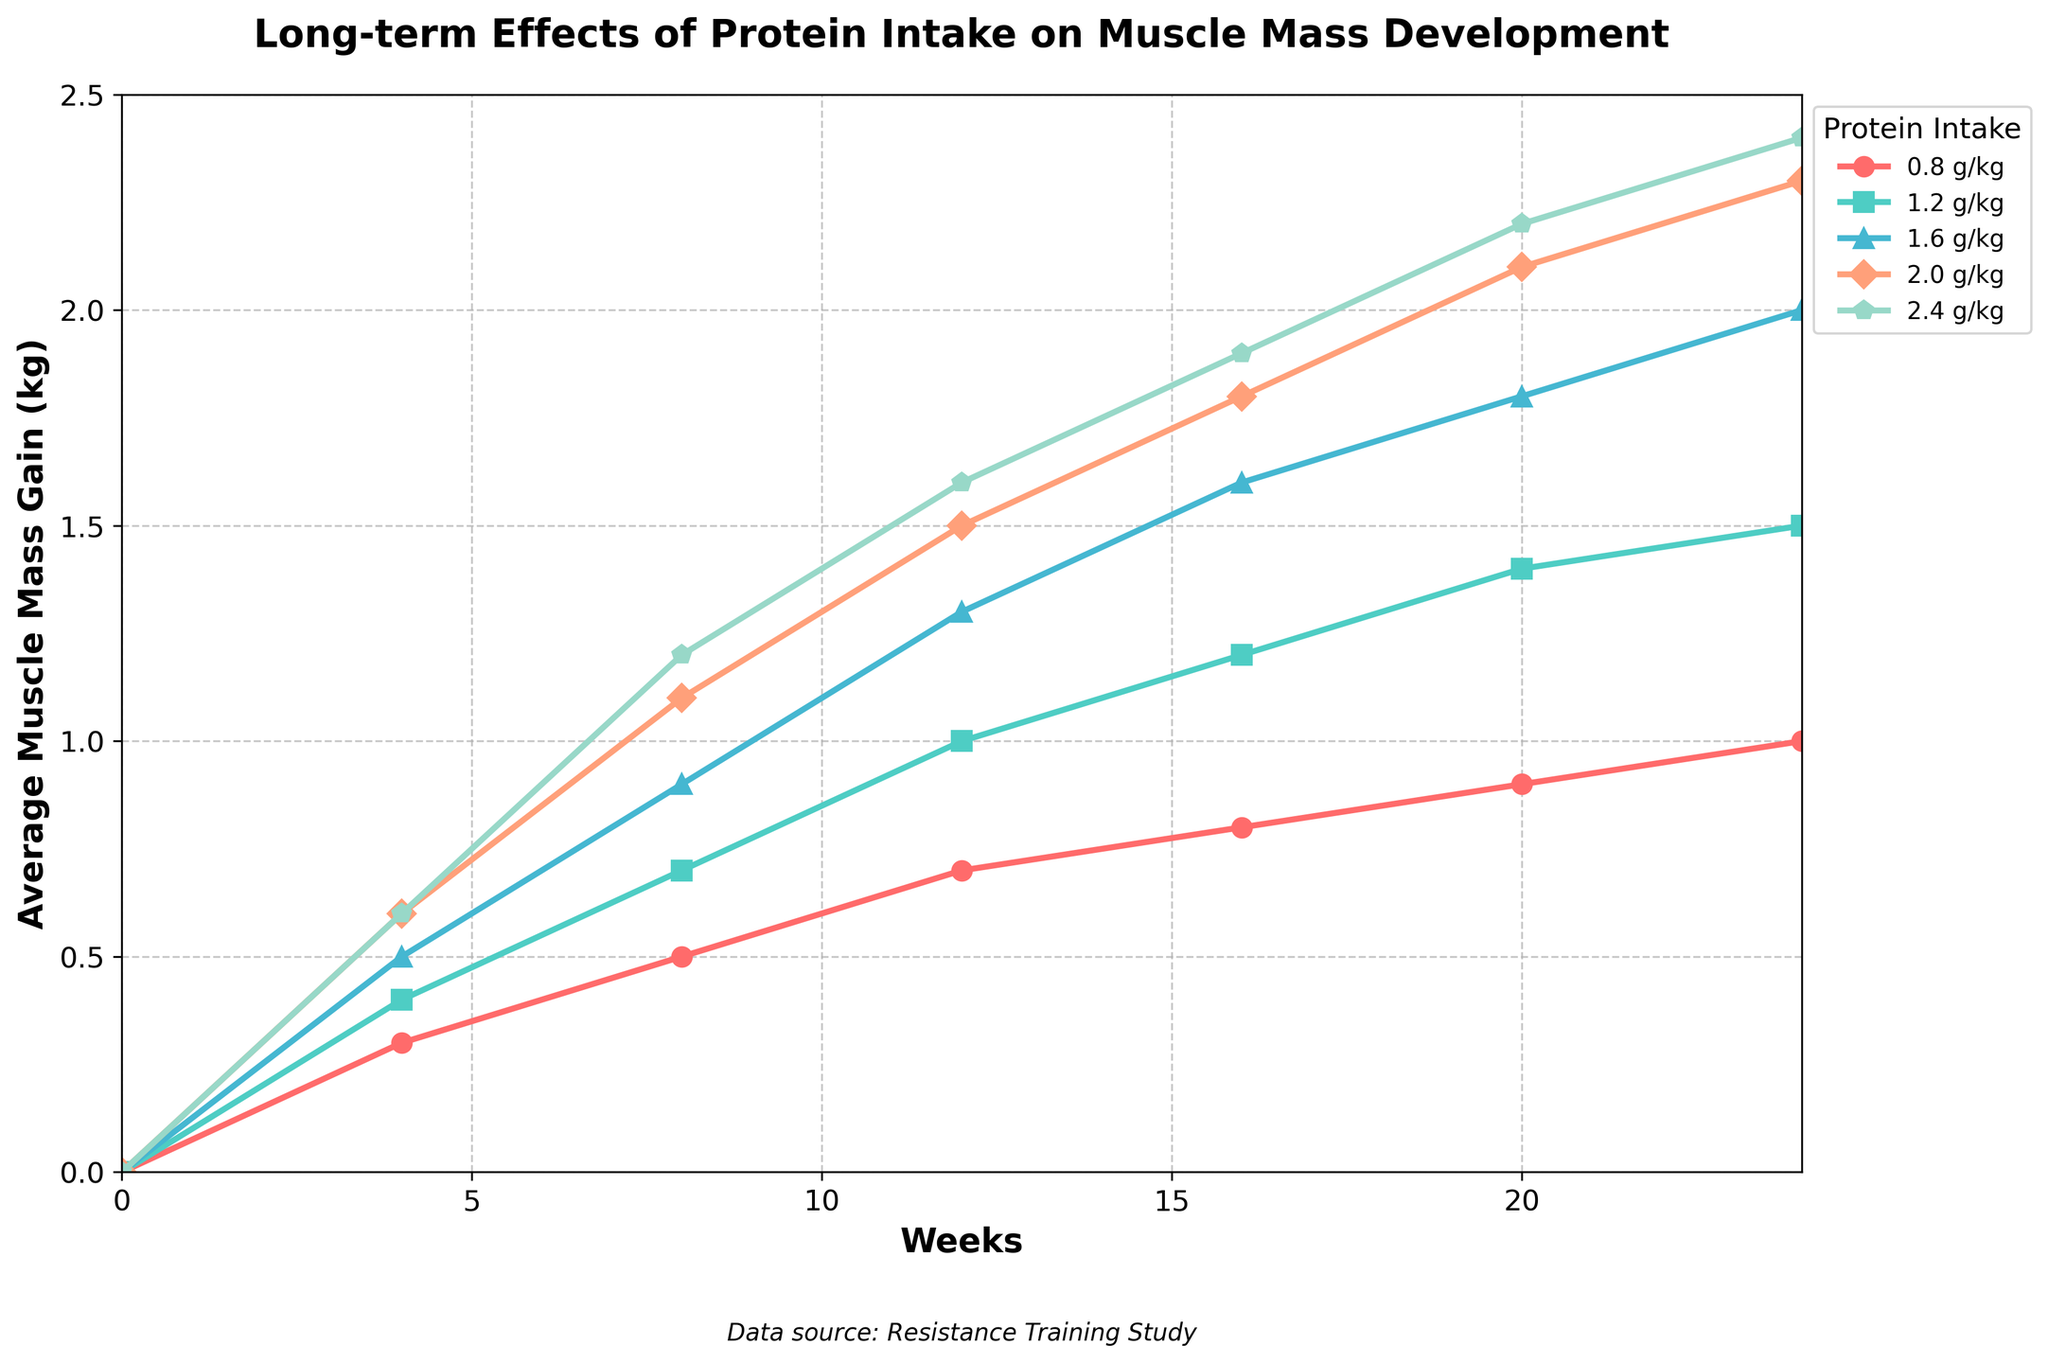Which protein intake level resulted in the highest muscle mass gain at 24 weeks? At 24 weeks, the lines indicating muscle mass gain for different protein intake levels can be compared. The 2.4 g/kg protein intake level reaches the highest point.
Answer: 2.4 g/kg How does the muscle mass gain at 12 weeks for a 1.2 g/kg protein intake compare to that of a 0.8 g/kg protein intake? At 12 weeks, locate the points for both 1.2 g/kg and 0.8 g/kg intake levels. The 1.2 g/kg intake shows a gain of 1.0 kg, while the 0.8 g/kg intake shows a gain of 0.7 kg. 1.0 kg is greater than 0.7 kg.
Answer: 1.0 kg is greater than 0.7 kg What is the difference in muscle mass gain between 2.0 g/kg and 1.6 g/kg protein intake at 16 weeks? At 16 weeks, identify the muscle mass gain for 2.0 g/kg and 1.6 g/kg. The values are 1.8 kg and 1.6 kg, respectively. The difference is 1.8 kg - 1.6 kg = 0.2 kg.
Answer: 0.2 kg Between which weeks did the 1.6 g/kg protein intake show the greatest increase in muscle mass gain? Examine the muscle mass gain at each interval for the 1.6 g/kg intake level. The largest increase happens between weeks 8 and 12, going from 0.9 kg to 1.3 kg, an increase of 0.4 kg.
Answer: Between weeks 8 and 12 Was there a week where the average muscle mass gain for the 0.8 g/kg and 1.2 g/kg protein levels was the same? Compare the muscle mass gain for 0.8 g/kg and 1.2 g/kg at each week. At no point do the values match across 24 weeks.
Answer: No What is the average muscle mass gain at 20 weeks across all protein intake levels? Take the muscle mass gains at 20 weeks for each intake level: 0.9 kg, 1.4 kg, 1.8 kg, 2.1 kg, and 2.2 kg. Sum these values: 0.9 + 1.4 + 1.8 + 2.1 + 2.2 = 8.4 kg. There are 5 levels, so divide by 5: 8.4 / 5 = 1.68 kg.
Answer: 1.68 kg Which protein intake level shows a consistent increase in muscle mass gain every 4 weeks? Examine each intake level's muscle mass gain increments every 4 weeks. All levels, from 0.8 g/kg to 2.4 g/kg, show a consistent increase every 4 weeks.
Answer: All levels By how much does the muscle mass gain increase for the 2.4 g/kg protein level from week 4 to week 8? For 2.4 g/kg protein intake from week 4 to week 8, the gain increases from 0.6 kg to 1.2 kg. The increase is 1.2 kg - 0.6 kg = 0.6 kg.
Answer: 0.6 kg 